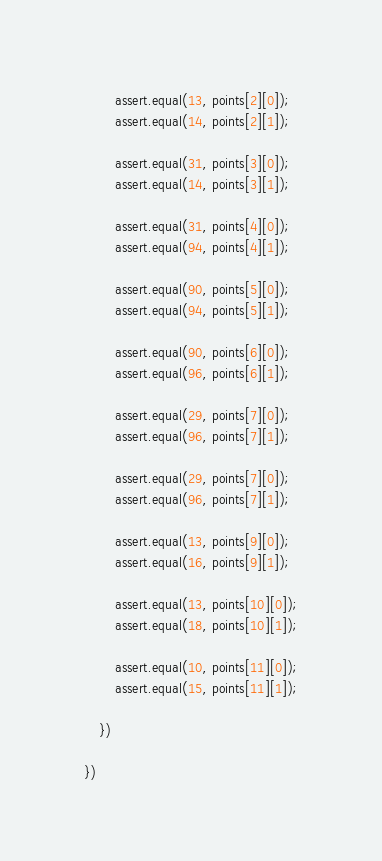Convert code to text. <code><loc_0><loc_0><loc_500><loc_500><_TypeScript_>
        assert.equal(13, points[2][0]);
        assert.equal(14, points[2][1]);

        assert.equal(31, points[3][0]);
        assert.equal(14, points[3][1]);

        assert.equal(31, points[4][0]);
        assert.equal(94, points[4][1]);

        assert.equal(90, points[5][0]);
        assert.equal(94, points[5][1]);

        assert.equal(90, points[6][0]);
        assert.equal(96, points[6][1]);

        assert.equal(29, points[7][0]);
        assert.equal(96, points[7][1]);

        assert.equal(29, points[7][0]);
        assert.equal(96, points[7][1]);

        assert.equal(13, points[9][0]);
        assert.equal(16, points[9][1]);

        assert.equal(13, points[10][0]);
        assert.equal(18, points[10][1]);
        
        assert.equal(10, points[11][0]);
        assert.equal(15, points[11][1]);

    })

})</code> 